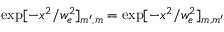Convert formula to latex. <formula><loc_0><loc_0><loc_500><loc_500>\exp [ - x ^ { 2 } / w _ { e } ^ { 2 } ] _ { m ^ { \prime } , m } = \exp [ - x ^ { 2 } / w _ { e } ^ { 2 } ] _ { m , m ^ { \prime } }</formula> 